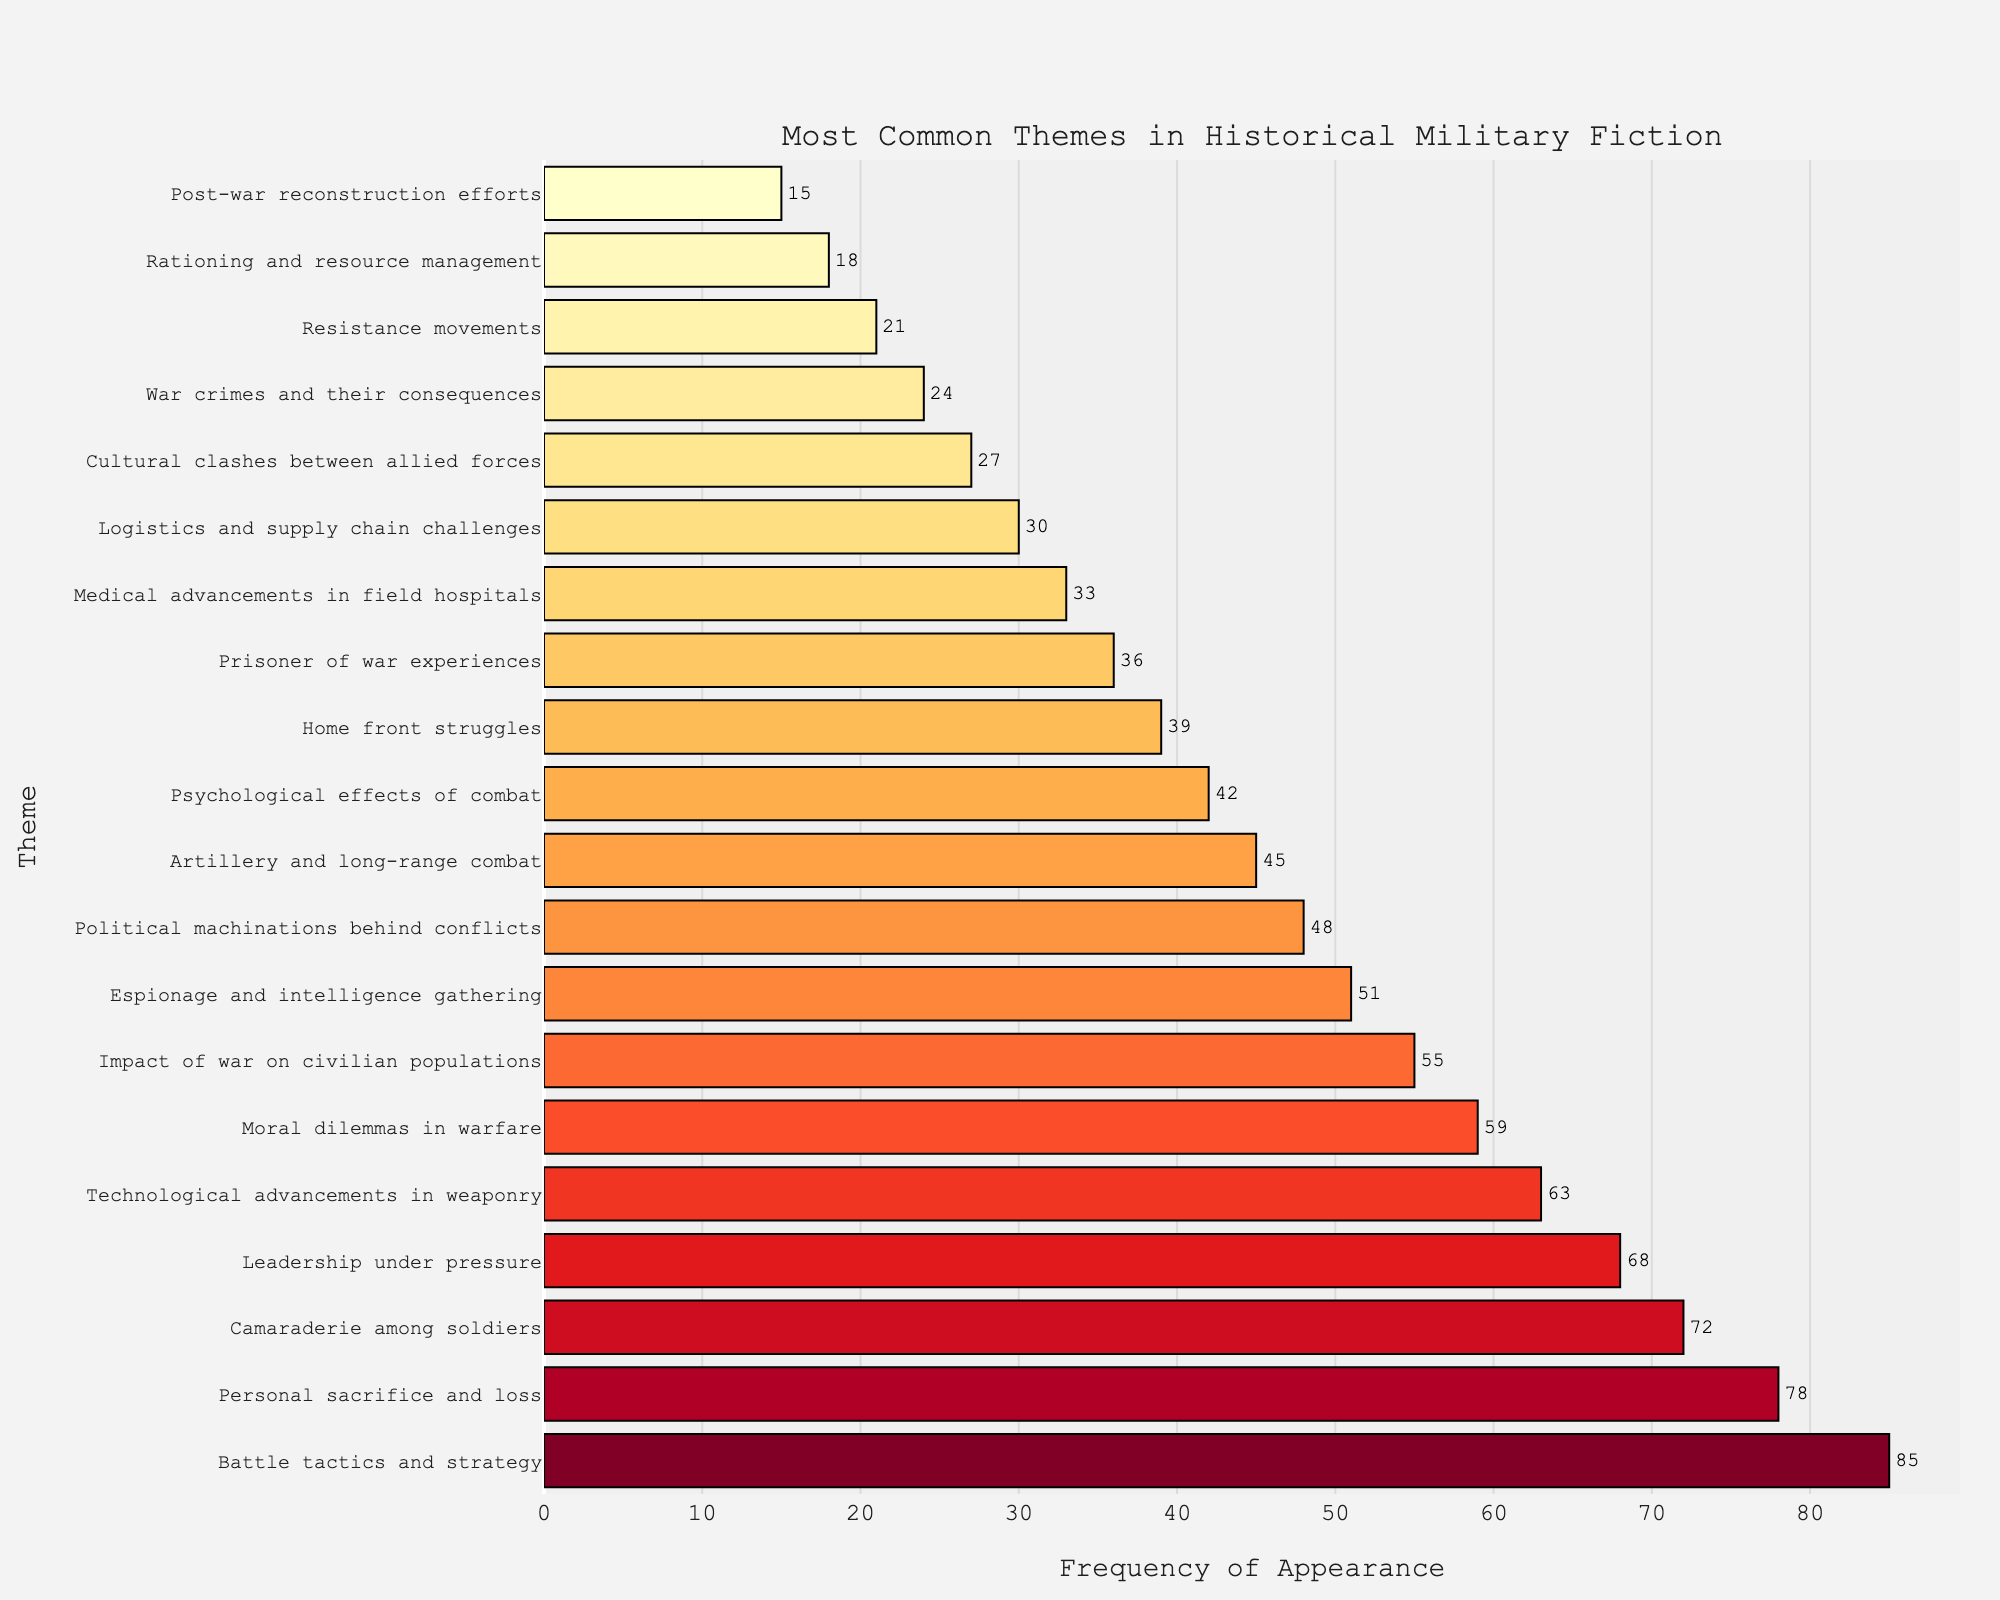What's the most common theme in historical military fiction according to the figure? The bar representing "Battle tactics and strategy" extends the furthest to the right, indicating it has the highest frequency of 85.
Answer: Battle tactics and strategy Which theme has a higher frequency, "Leadership under pressure" or "Artillery and long-range combat"? Compare the lengths of the bars for "Leadership under pressure" and "Artillery and long-range combat". "Leadership under pressure" has a frequency of 68, while "Artillery and long-range combat" has a frequency of 45.
Answer: Leadership under pressure What is the sum of the frequencies of the top three themes? The top three themes are "Battle tactics and strategy" (85), "Personal sacrifice and loss" (78), and "Camaraderie among soldiers" (72). Summing these gives 85 + 78 + 72 = 235.
Answer: 235 How many themes have a frequency greater than or equal to 50? Check the bars extending past the 50 mark. The themes are: "Battle tactics and strategy" (85), "Personal sacrifice and loss" (78), "Camaraderie among soldiers" (72), "Leadership under pressure" (68), "Technological advancements in weaponry" (63), "Moral dilemmas in warfare" (59), "Impact of war on civilian populations" (55), and "Espionage and intelligence gathering" (51), totaling 8 themes.
Answer: 8 Which theme has a frequency nearest to the midpoint between the highest and lowest frequencies? First calculate the midpoint (85 + 15) / 2 = 50. The frequency closest to 50 is "Espionage and intelligence gathering" with 51.
Answer: Espionage and intelligence gathering What is the average frequency of themes with more than 60 appearances? The themes are: "Battle tactics and strategy" (85), "Personal sacrifice and loss" (78), "Camaraderie among soldiers" (72), "Leadership under pressure" (68), "Technological advancements in weaponry" (63). Sum these (85 + 78 + 72 + 68 + 63) = 366. The average is 366 / 5 = 73.2.
Answer: 73.2 Which themes have a frequency lower than but nearest to "Espionage and intelligence gathering"? "Espionage and intelligence gathering" has a frequency of 51. The theme with frequency just under is "Political machinations behind conflicts" at 48.
Answer: Political machinations behind conflicts Is the frequency of "Moral dilemmas in warfare" closer to "Technological advancements in weaponry" or "Personal sacrifice and loss"? "Moral dilemmas in warfare" has a frequency of 59. Compare distances: 59 - 63 = -4 (to "Technological advancements in weaponry") and 78 - 59 = 19 (to "Personal sacrifice and loss"). Hence 4 < 19, it is closer to "Technological advancements in weaponry".
Answer: Technological advancements in weaponry 